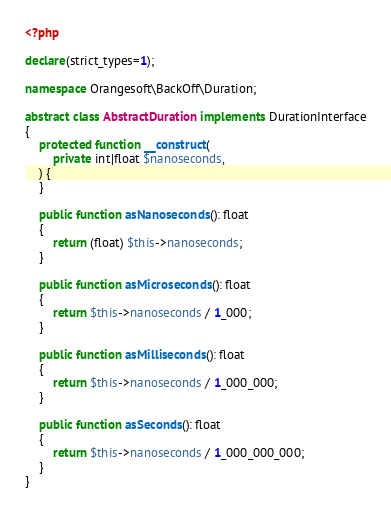<code> <loc_0><loc_0><loc_500><loc_500><_PHP_><?php

declare(strict_types=1);

namespace Orangesoft\BackOff\Duration;

abstract class AbstractDuration implements DurationInterface
{
    protected function __construct(
        private int|float $nanoseconds,
    ) {
    }

    public function asNanoseconds(): float
    {
        return (float) $this->nanoseconds;
    }

    public function asMicroseconds(): float
    {
        return $this->nanoseconds / 1_000;
    }

    public function asMilliseconds(): float
    {
        return $this->nanoseconds / 1_000_000;
    }

    public function asSeconds(): float
    {
        return $this->nanoseconds / 1_000_000_000;
    }
}
</code> 